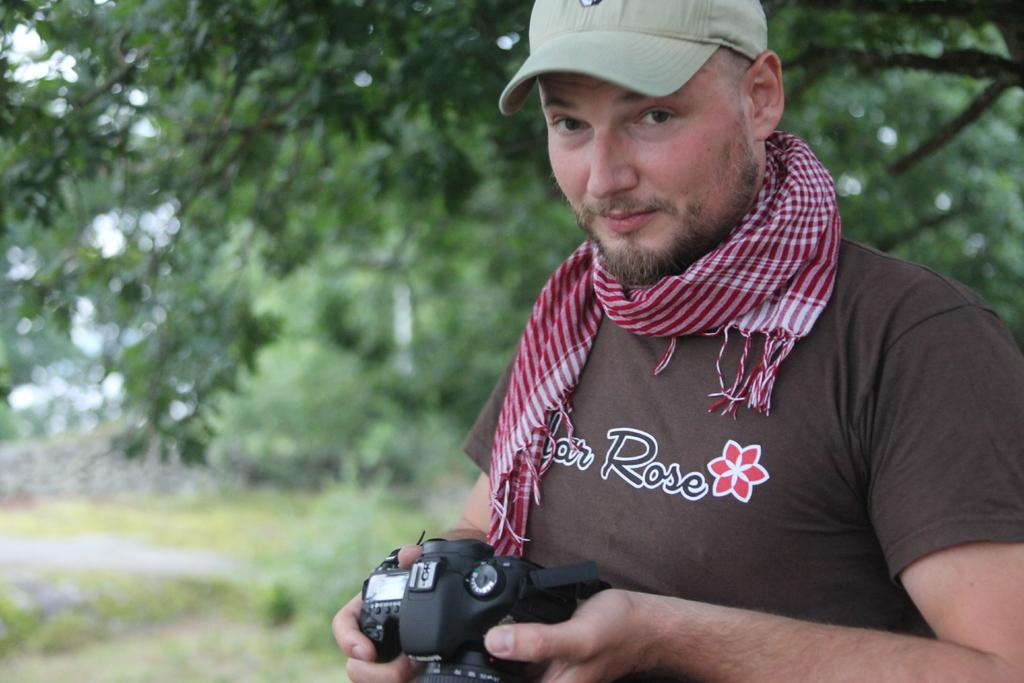Who is the main subject in the image? There is a man in the image. What is the man holding in his hand? The man is holding a camera in his hand. What can be seen in the background of the image? There are trees in the background of the image. What type of gun is the man holding in the image? There is no gun present in the image; the man is holding a camera. 